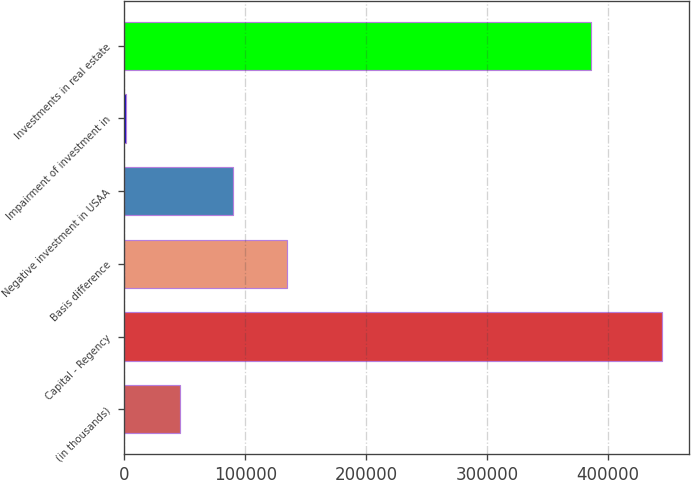Convert chart to OTSL. <chart><loc_0><loc_0><loc_500><loc_500><bar_chart><fcel>(in thousands)<fcel>Capital - Regency<fcel>Basis difference<fcel>Negative investment in USAA<fcel>Impairment of investment in<fcel>Investments in real estate<nl><fcel>45676.8<fcel>445068<fcel>134430<fcel>90053.6<fcel>1300<fcel>386304<nl></chart> 